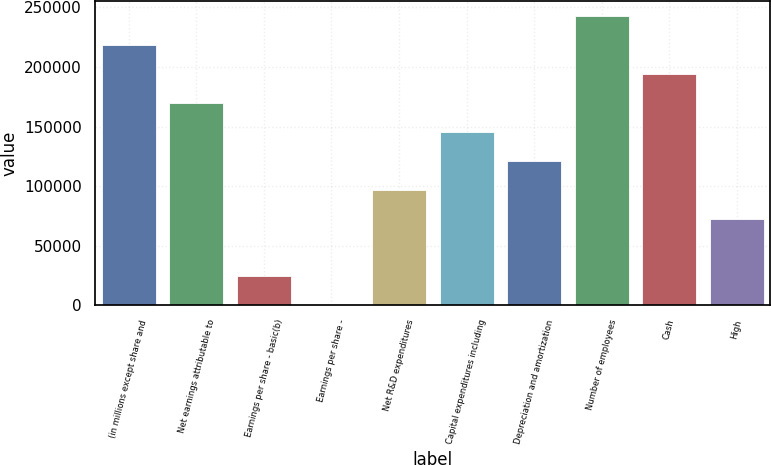Convert chart to OTSL. <chart><loc_0><loc_0><loc_500><loc_500><bar_chart><fcel>(in millions except share and<fcel>Net earnings attributable to<fcel>Earnings per share - basic(b)<fcel>Earnings per share -<fcel>Net R&D expenditures<fcel>Capital expenditures including<fcel>Depreciation and amortization<fcel>Number of employees<fcel>Cash<fcel>High<nl><fcel>218479<fcel>169928<fcel>24277.3<fcel>2.09<fcel>97102.9<fcel>145653<fcel>121378<fcel>242754<fcel>194204<fcel>72827.7<nl></chart> 